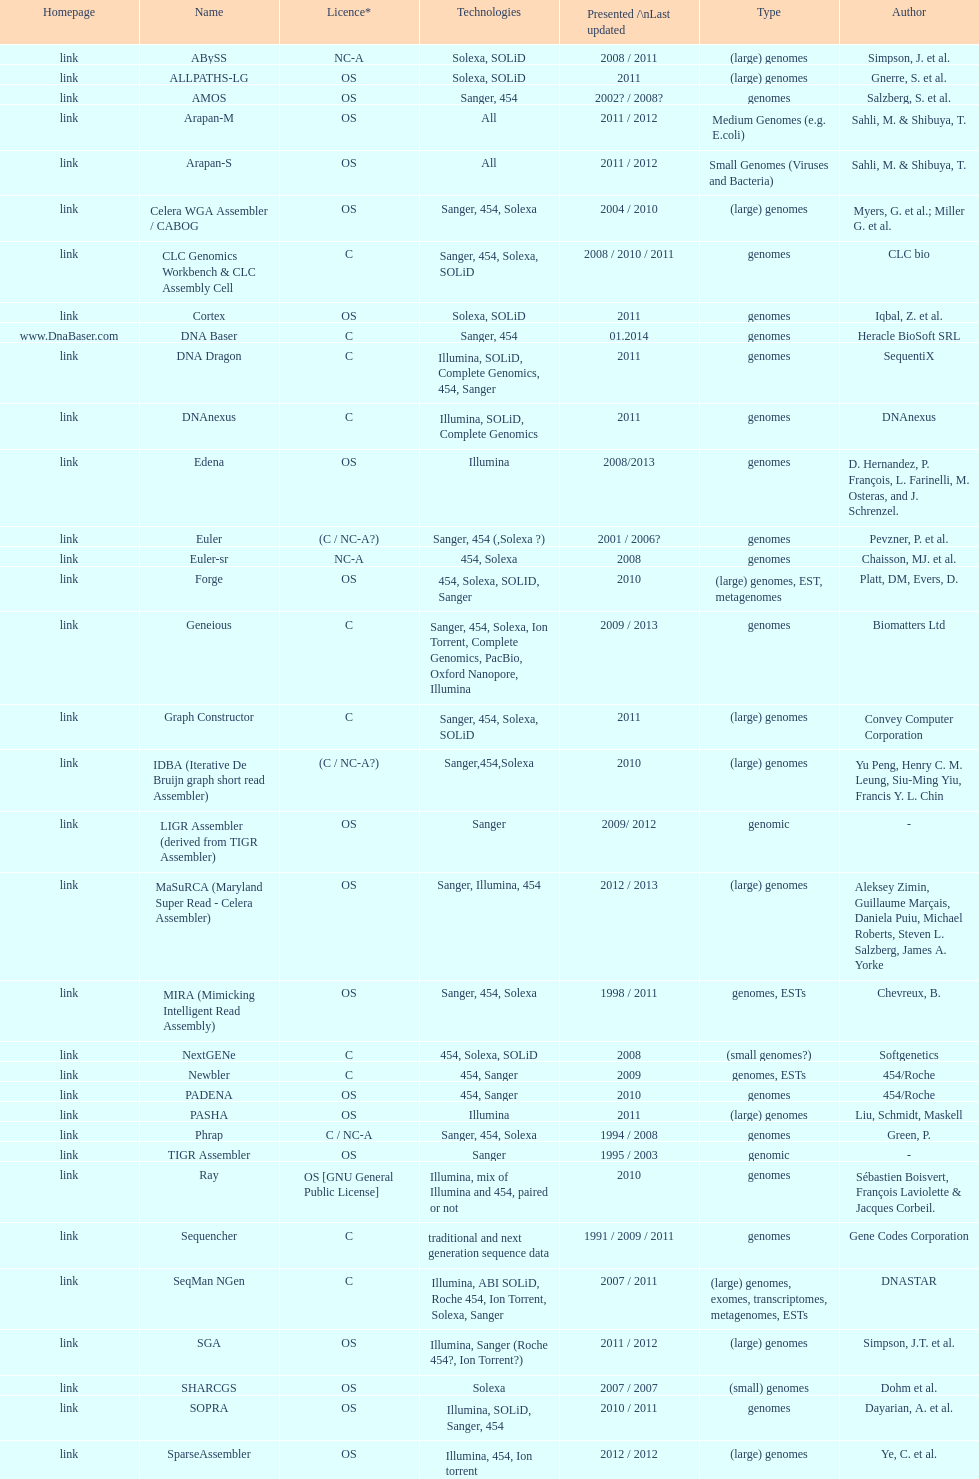What is the total number of assemblers supporting small genomes type technologies? 9. 